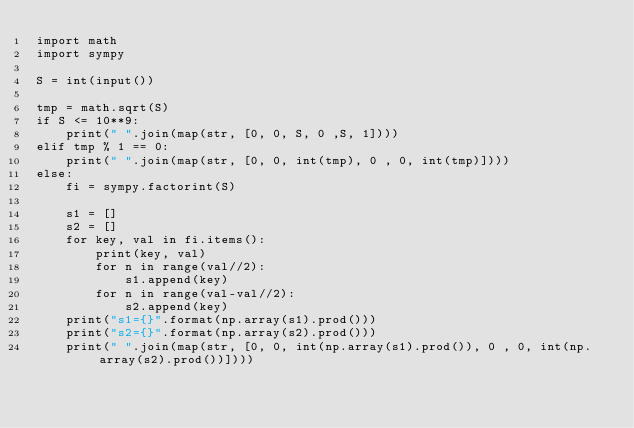<code> <loc_0><loc_0><loc_500><loc_500><_Python_>import math
import sympy

S = int(input())

tmp = math.sqrt(S)
if S <= 10**9:
    print(" ".join(map(str, [0, 0, S, 0 ,S, 1])))
elif tmp % 1 == 0:
    print(" ".join(map(str, [0, 0, int(tmp), 0 , 0, int(tmp)])))
else:
    fi = sympy.factorint(S)

    s1 = []
    s2 = []
    for key, val in fi.items():
        print(key, val)
        for n in range(val//2):
            s1.append(key)
        for n in range(val-val//2):
            s2.append(key)
    print("s1={}".format(np.array(s1).prod()))
    print("s2={}".format(np.array(s2).prod()))  
    print(" ".join(map(str, [0, 0, int(np.array(s1).prod()), 0 , 0, int(np.array(s2).prod())])))</code> 